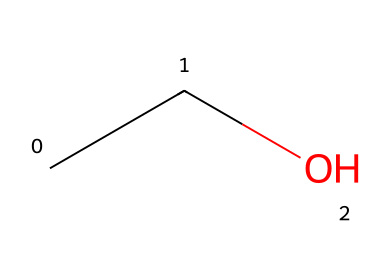What is the molecular formula of the chemical represented by the SMILES notation? The SMILES notation "CCO" indicates the presence of two carbon atoms (C), six hydrogen atoms (H), and one oxygen atom (O) in the molecule. Therefore, the molecular formula can be derived as C2H6O.
Answer: C2H6O How many carbon atoms are present in this compound? By examining the SMILES notation "CCO", we can see that there are two 'C' symbols, which represent carbon atoms. Therefore, there are two carbon atoms in this compound.
Answer: 2 What is the functional group present in ethanol? The structure includes an -OH group (hydroxyl group) indicated by the terminal 'O' attached to the last carbon in the SMILES representation, which characterizes ethanol as an alcohol.
Answer: hydroxyl group Is ethanol a polar or non-polar solvent? The presence of the hydroxyl functional group (-OH) creates a significant polarity in the molecule due to the electronegativity difference between oxygen and hydrogen; thus, ethanol is classified as a polar solvent.
Answer: polar What type of chemical is ethanol primarily used as? Ethanol is commonly used as a solvent due to its ability to dissolve both polar and non-polar substances, making it versatile in various chemical applications.
Answer: solvent How many hydrogen atoms are bonded to the carbon atoms in ethanol? In the SMILES "CCO", the first carbon (C) is bonded to three hydrogen atoms (CH3), and the second carbon is bonded to two hydrogen atoms (CH2), totaling five hydrogen atoms.
Answer: 6 